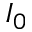Convert formula to latex. <formula><loc_0><loc_0><loc_500><loc_500>I _ { 0 }</formula> 